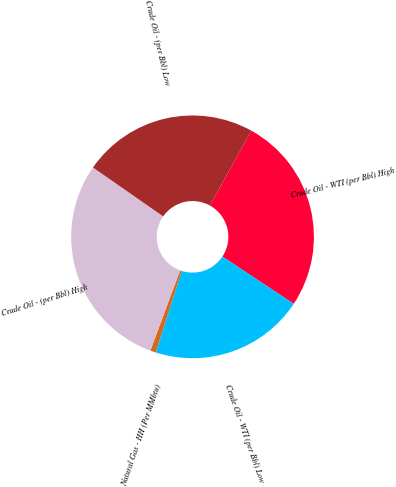Convert chart. <chart><loc_0><loc_0><loc_500><loc_500><pie_chart><fcel>Crude Oil - WTI (per Bbl) High<fcel>Crude Oil - WTI (per Bbl) Low<fcel>Natural Gas - HH (Per MMbtu)<fcel>Crude Oil - (per Bbl) High<fcel>Crude Oil - (per Bbl) Low<nl><fcel>26.27%<fcel>20.6%<fcel>0.74%<fcel>29.03%<fcel>23.36%<nl></chart> 